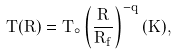<formula> <loc_0><loc_0><loc_500><loc_500>T ( R ) = T _ { \circ } \left ( \frac { R } { R _ { f } } \right ) ^ { - q } ( K ) ,</formula> 